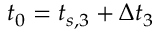Convert formula to latex. <formula><loc_0><loc_0><loc_500><loc_500>t _ { 0 } = t _ { s , 3 } + \Delta t _ { 3 }</formula> 